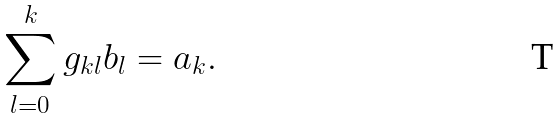<formula> <loc_0><loc_0><loc_500><loc_500>\sum _ { l = 0 } ^ { k } g _ { k l } b _ { l } = a _ { k } .</formula> 